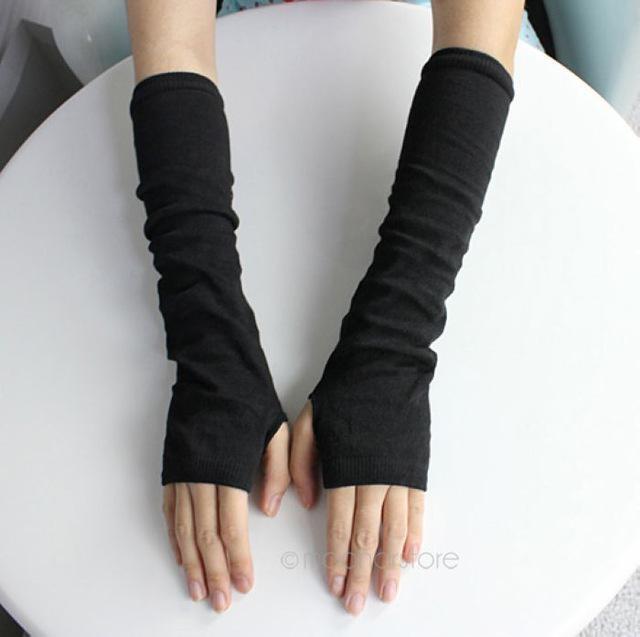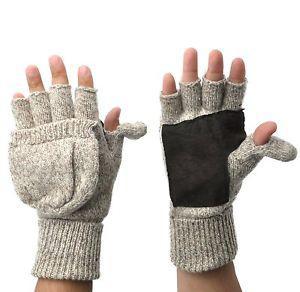The first image is the image on the left, the second image is the image on the right. Evaluate the accuracy of this statement regarding the images: "Each image shows a pair of completely fingerless 'gloves' worn by a model, and the hands wearing gloves are posed fingers-up on the left, and fingers-down on the right.". Is it true? Answer yes or no. No. The first image is the image on the left, the second image is the image on the right. Considering the images on both sides, is "A white pair of gloves is modeled on crossed hands, while a casual knit pair is modeled side by side." valid? Answer yes or no. No. 